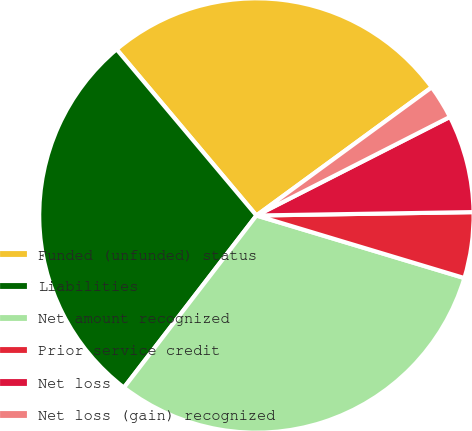<chart> <loc_0><loc_0><loc_500><loc_500><pie_chart><fcel>Funded (unfunded) status<fcel>Liabilities<fcel>Net amount recognized<fcel>Prior service credit<fcel>Net loss<fcel>Net loss (gain) recognized<nl><fcel>26.08%<fcel>28.43%<fcel>30.79%<fcel>4.9%<fcel>7.25%<fcel>2.55%<nl></chart> 